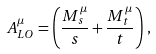<formula> <loc_0><loc_0><loc_500><loc_500>A _ { L O } ^ { \mu } = \left ( \frac { M _ { s } ^ { \mu } } { s } + \frac { M _ { t } ^ { \mu } } { t } \right ) \, ,</formula> 